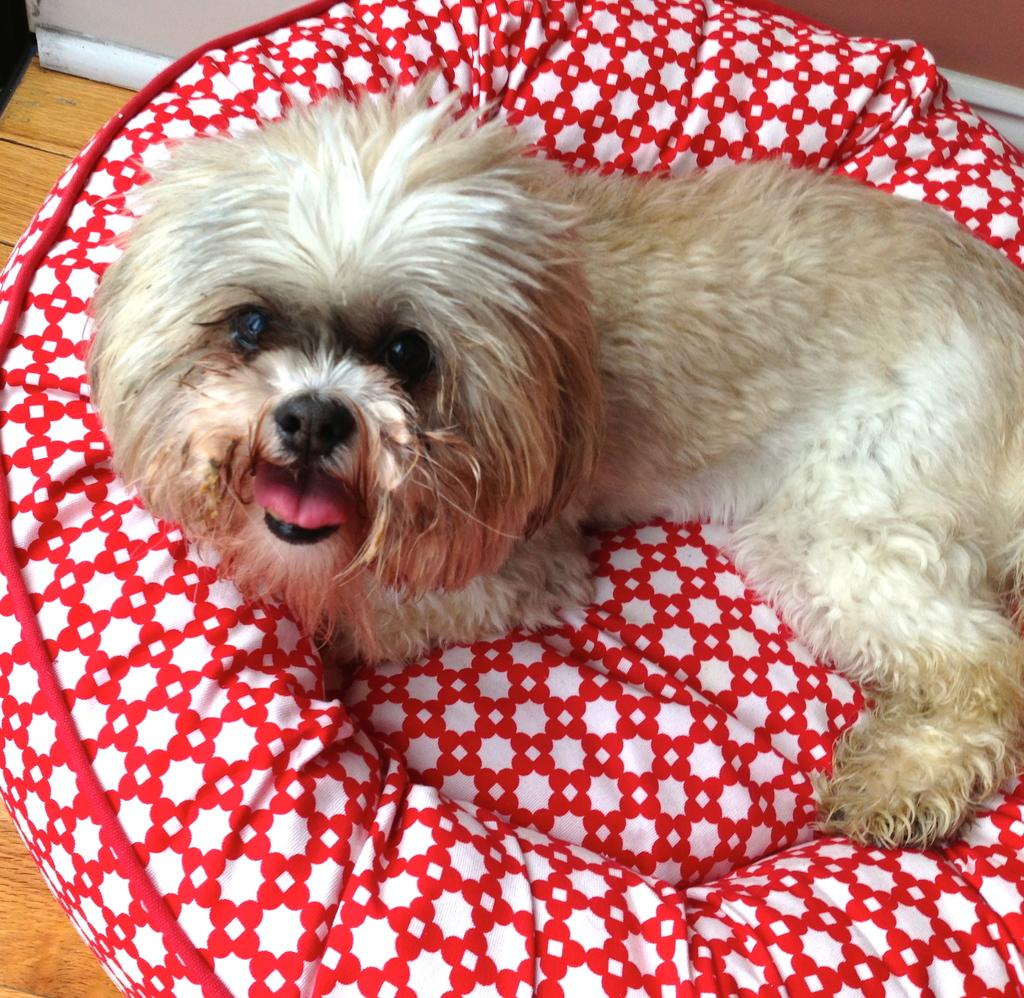What type of animal is in the image? There is a dog in the image. Where is the dog located? The dog is on a couch. What is the surface beneath the couch? The couch is on a wooden floor. What type of coat is the dog wearing in the image? The dog is not wearing a coat in the image. How does the thrill of the dog's presence affect the wooden floor? The image does not depict any emotions or feelings, so it is not possible to determine the thrill of the dog's presence or how it might affect the wooden floor. 